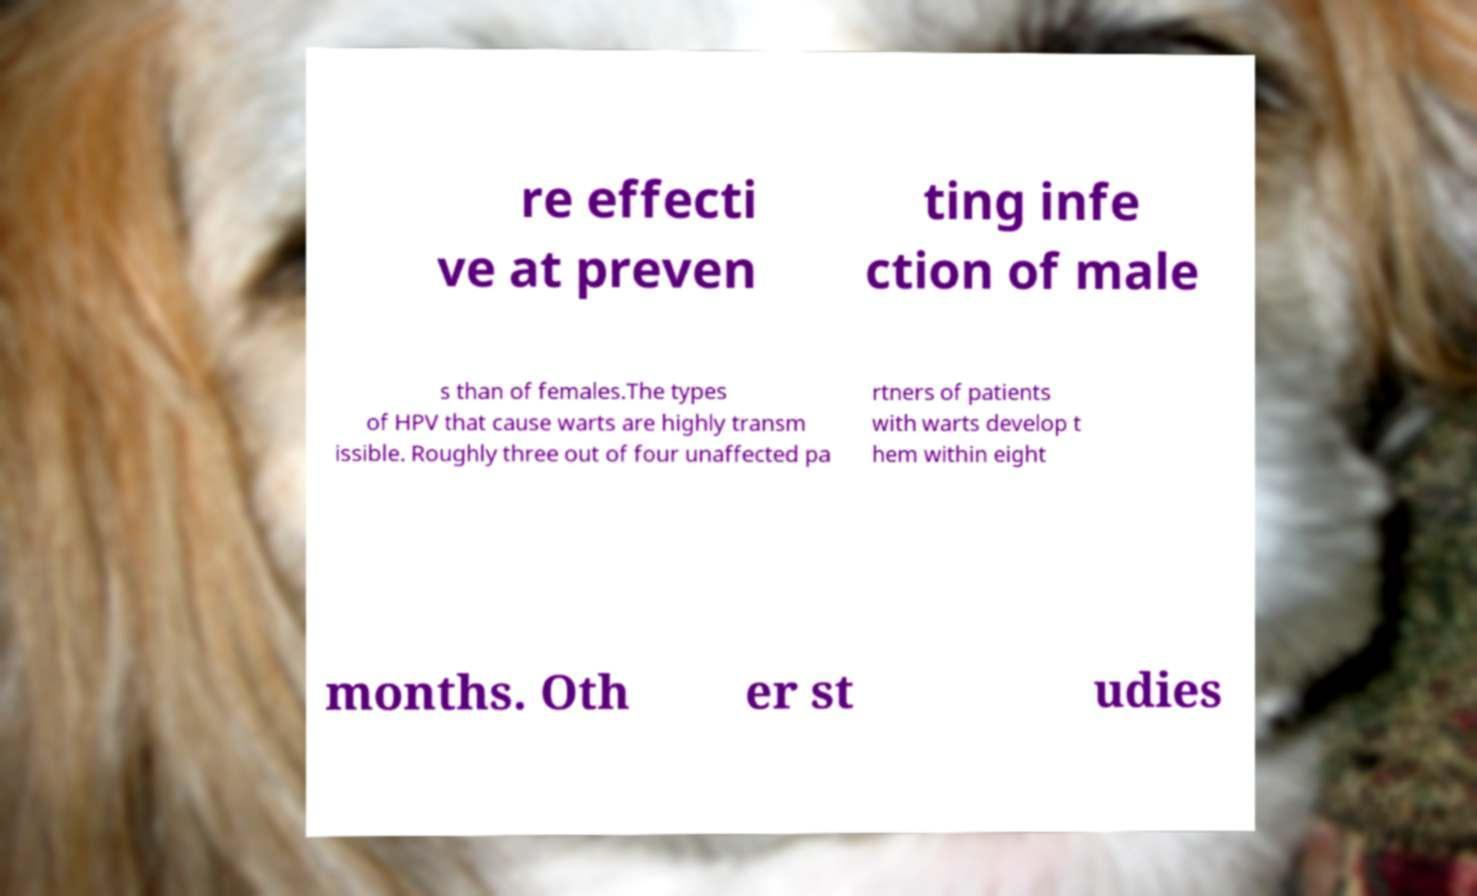Can you read and provide the text displayed in the image?This photo seems to have some interesting text. Can you extract and type it out for me? re effecti ve at preven ting infe ction of male s than of females.The types of HPV that cause warts are highly transm issible. Roughly three out of four unaffected pa rtners of patients with warts develop t hem within eight months. Oth er st udies 